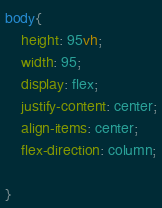Convert code to text. <code><loc_0><loc_0><loc_500><loc_500><_CSS_>body{
    height: 95vh;
    width: 95;
    display: flex;
    justify-content: center;
    align-items: center;
    flex-direction: column;
    
}</code> 